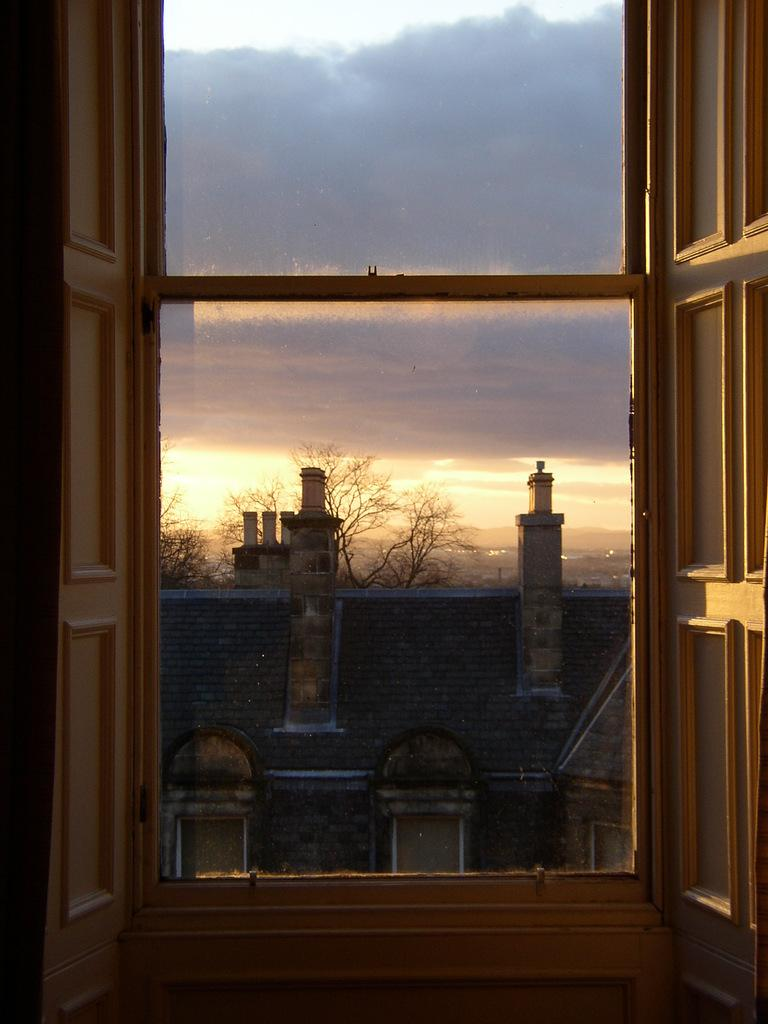What type of windows are present in the image? There are glass windows in the image. What can be seen through the windows? Buildings, trees, and the sky are visible through the windows. What is the condition of the sky in the image? Clouds are present in the sky. How many snakes are slithering on the windows in the image? There are no snakes present in the image; it features glass windows with views of buildings, trees, and the sky. 